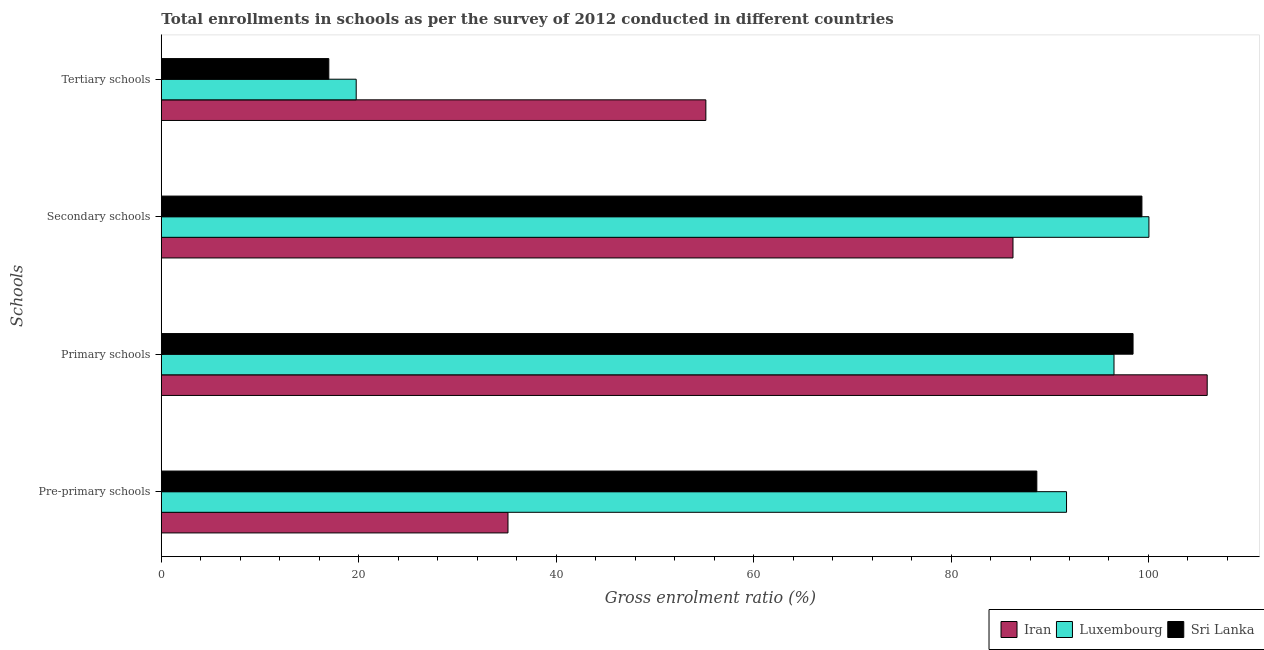How many different coloured bars are there?
Your answer should be compact. 3. How many groups of bars are there?
Your answer should be compact. 4. Are the number of bars on each tick of the Y-axis equal?
Ensure brevity in your answer.  Yes. How many bars are there on the 1st tick from the top?
Make the answer very short. 3. What is the label of the 3rd group of bars from the top?
Offer a very short reply. Primary schools. What is the gross enrolment ratio in tertiary schools in Sri Lanka?
Provide a succinct answer. 16.97. Across all countries, what is the maximum gross enrolment ratio in tertiary schools?
Offer a very short reply. 55.16. Across all countries, what is the minimum gross enrolment ratio in tertiary schools?
Keep it short and to the point. 16.97. In which country was the gross enrolment ratio in tertiary schools maximum?
Your response must be concise. Iran. In which country was the gross enrolment ratio in primary schools minimum?
Offer a very short reply. Luxembourg. What is the total gross enrolment ratio in tertiary schools in the graph?
Provide a short and direct response. 91.88. What is the difference between the gross enrolment ratio in pre-primary schools in Iran and that in Luxembourg?
Offer a very short reply. -56.58. What is the difference between the gross enrolment ratio in primary schools in Sri Lanka and the gross enrolment ratio in tertiary schools in Luxembourg?
Your response must be concise. 78.7. What is the average gross enrolment ratio in tertiary schools per country?
Make the answer very short. 30.63. What is the difference between the gross enrolment ratio in secondary schools and gross enrolment ratio in pre-primary schools in Iran?
Your response must be concise. 51.16. In how many countries, is the gross enrolment ratio in tertiary schools greater than 84 %?
Your answer should be very brief. 0. What is the ratio of the gross enrolment ratio in primary schools in Luxembourg to that in Sri Lanka?
Your answer should be very brief. 0.98. Is the gross enrolment ratio in tertiary schools in Iran less than that in Luxembourg?
Provide a succinct answer. No. What is the difference between the highest and the second highest gross enrolment ratio in primary schools?
Your answer should be very brief. 7.51. What is the difference between the highest and the lowest gross enrolment ratio in primary schools?
Your answer should be compact. 9.44. Is it the case that in every country, the sum of the gross enrolment ratio in secondary schools and gross enrolment ratio in primary schools is greater than the sum of gross enrolment ratio in pre-primary schools and gross enrolment ratio in tertiary schools?
Ensure brevity in your answer.  Yes. What does the 3rd bar from the top in Tertiary schools represents?
Your answer should be compact. Iran. What does the 3rd bar from the bottom in Primary schools represents?
Make the answer very short. Sri Lanka. Is it the case that in every country, the sum of the gross enrolment ratio in pre-primary schools and gross enrolment ratio in primary schools is greater than the gross enrolment ratio in secondary schools?
Your answer should be very brief. Yes. Are all the bars in the graph horizontal?
Provide a short and direct response. Yes. How many countries are there in the graph?
Keep it short and to the point. 3. Does the graph contain any zero values?
Keep it short and to the point. No. Does the graph contain grids?
Offer a very short reply. No. How are the legend labels stacked?
Keep it short and to the point. Horizontal. What is the title of the graph?
Provide a succinct answer. Total enrollments in schools as per the survey of 2012 conducted in different countries. What is the label or title of the X-axis?
Your answer should be very brief. Gross enrolment ratio (%). What is the label or title of the Y-axis?
Offer a terse response. Schools. What is the Gross enrolment ratio (%) in Iran in Pre-primary schools?
Your answer should be very brief. 35.12. What is the Gross enrolment ratio (%) of Luxembourg in Pre-primary schools?
Offer a terse response. 91.7. What is the Gross enrolment ratio (%) of Sri Lanka in Pre-primary schools?
Make the answer very short. 88.69. What is the Gross enrolment ratio (%) in Iran in Primary schools?
Your answer should be very brief. 105.95. What is the Gross enrolment ratio (%) of Luxembourg in Primary schools?
Make the answer very short. 96.51. What is the Gross enrolment ratio (%) of Sri Lanka in Primary schools?
Give a very brief answer. 98.44. What is the Gross enrolment ratio (%) of Iran in Secondary schools?
Offer a very short reply. 86.28. What is the Gross enrolment ratio (%) of Luxembourg in Secondary schools?
Provide a succinct answer. 100.05. What is the Gross enrolment ratio (%) of Sri Lanka in Secondary schools?
Your response must be concise. 99.34. What is the Gross enrolment ratio (%) of Iran in Tertiary schools?
Ensure brevity in your answer.  55.16. What is the Gross enrolment ratio (%) in Luxembourg in Tertiary schools?
Make the answer very short. 19.74. What is the Gross enrolment ratio (%) in Sri Lanka in Tertiary schools?
Your response must be concise. 16.97. Across all Schools, what is the maximum Gross enrolment ratio (%) of Iran?
Ensure brevity in your answer.  105.95. Across all Schools, what is the maximum Gross enrolment ratio (%) in Luxembourg?
Provide a short and direct response. 100.05. Across all Schools, what is the maximum Gross enrolment ratio (%) of Sri Lanka?
Give a very brief answer. 99.34. Across all Schools, what is the minimum Gross enrolment ratio (%) in Iran?
Offer a very short reply. 35.12. Across all Schools, what is the minimum Gross enrolment ratio (%) in Luxembourg?
Provide a succinct answer. 19.74. Across all Schools, what is the minimum Gross enrolment ratio (%) in Sri Lanka?
Your answer should be compact. 16.97. What is the total Gross enrolment ratio (%) in Iran in the graph?
Offer a terse response. 282.51. What is the total Gross enrolment ratio (%) of Luxembourg in the graph?
Keep it short and to the point. 308. What is the total Gross enrolment ratio (%) of Sri Lanka in the graph?
Provide a short and direct response. 303.44. What is the difference between the Gross enrolment ratio (%) of Iran in Pre-primary schools and that in Primary schools?
Provide a short and direct response. -70.83. What is the difference between the Gross enrolment ratio (%) of Luxembourg in Pre-primary schools and that in Primary schools?
Keep it short and to the point. -4.81. What is the difference between the Gross enrolment ratio (%) of Sri Lanka in Pre-primary schools and that in Primary schools?
Keep it short and to the point. -9.75. What is the difference between the Gross enrolment ratio (%) in Iran in Pre-primary schools and that in Secondary schools?
Your answer should be compact. -51.16. What is the difference between the Gross enrolment ratio (%) in Luxembourg in Pre-primary schools and that in Secondary schools?
Keep it short and to the point. -8.35. What is the difference between the Gross enrolment ratio (%) in Sri Lanka in Pre-primary schools and that in Secondary schools?
Provide a succinct answer. -10.65. What is the difference between the Gross enrolment ratio (%) of Iran in Pre-primary schools and that in Tertiary schools?
Offer a terse response. -20.05. What is the difference between the Gross enrolment ratio (%) of Luxembourg in Pre-primary schools and that in Tertiary schools?
Offer a terse response. 71.96. What is the difference between the Gross enrolment ratio (%) of Sri Lanka in Pre-primary schools and that in Tertiary schools?
Provide a succinct answer. 71.73. What is the difference between the Gross enrolment ratio (%) of Iran in Primary schools and that in Secondary schools?
Give a very brief answer. 19.67. What is the difference between the Gross enrolment ratio (%) in Luxembourg in Primary schools and that in Secondary schools?
Ensure brevity in your answer.  -3.54. What is the difference between the Gross enrolment ratio (%) in Sri Lanka in Primary schools and that in Secondary schools?
Make the answer very short. -0.9. What is the difference between the Gross enrolment ratio (%) of Iran in Primary schools and that in Tertiary schools?
Your answer should be very brief. 50.79. What is the difference between the Gross enrolment ratio (%) in Luxembourg in Primary schools and that in Tertiary schools?
Offer a terse response. 76.77. What is the difference between the Gross enrolment ratio (%) of Sri Lanka in Primary schools and that in Tertiary schools?
Offer a terse response. 81.47. What is the difference between the Gross enrolment ratio (%) in Iran in Secondary schools and that in Tertiary schools?
Your answer should be compact. 31.11. What is the difference between the Gross enrolment ratio (%) in Luxembourg in Secondary schools and that in Tertiary schools?
Offer a terse response. 80.3. What is the difference between the Gross enrolment ratio (%) in Sri Lanka in Secondary schools and that in Tertiary schools?
Your response must be concise. 82.37. What is the difference between the Gross enrolment ratio (%) in Iran in Pre-primary schools and the Gross enrolment ratio (%) in Luxembourg in Primary schools?
Provide a succinct answer. -61.39. What is the difference between the Gross enrolment ratio (%) in Iran in Pre-primary schools and the Gross enrolment ratio (%) in Sri Lanka in Primary schools?
Provide a short and direct response. -63.32. What is the difference between the Gross enrolment ratio (%) of Luxembourg in Pre-primary schools and the Gross enrolment ratio (%) of Sri Lanka in Primary schools?
Provide a short and direct response. -6.74. What is the difference between the Gross enrolment ratio (%) in Iran in Pre-primary schools and the Gross enrolment ratio (%) in Luxembourg in Secondary schools?
Make the answer very short. -64.93. What is the difference between the Gross enrolment ratio (%) of Iran in Pre-primary schools and the Gross enrolment ratio (%) of Sri Lanka in Secondary schools?
Ensure brevity in your answer.  -64.22. What is the difference between the Gross enrolment ratio (%) in Luxembourg in Pre-primary schools and the Gross enrolment ratio (%) in Sri Lanka in Secondary schools?
Make the answer very short. -7.64. What is the difference between the Gross enrolment ratio (%) in Iran in Pre-primary schools and the Gross enrolment ratio (%) in Luxembourg in Tertiary schools?
Give a very brief answer. 15.38. What is the difference between the Gross enrolment ratio (%) of Iran in Pre-primary schools and the Gross enrolment ratio (%) of Sri Lanka in Tertiary schools?
Provide a short and direct response. 18.15. What is the difference between the Gross enrolment ratio (%) in Luxembourg in Pre-primary schools and the Gross enrolment ratio (%) in Sri Lanka in Tertiary schools?
Give a very brief answer. 74.73. What is the difference between the Gross enrolment ratio (%) in Iran in Primary schools and the Gross enrolment ratio (%) in Luxembourg in Secondary schools?
Your answer should be very brief. 5.9. What is the difference between the Gross enrolment ratio (%) in Iran in Primary schools and the Gross enrolment ratio (%) in Sri Lanka in Secondary schools?
Ensure brevity in your answer.  6.61. What is the difference between the Gross enrolment ratio (%) in Luxembourg in Primary schools and the Gross enrolment ratio (%) in Sri Lanka in Secondary schools?
Provide a short and direct response. -2.83. What is the difference between the Gross enrolment ratio (%) in Iran in Primary schools and the Gross enrolment ratio (%) in Luxembourg in Tertiary schools?
Make the answer very short. 86.21. What is the difference between the Gross enrolment ratio (%) in Iran in Primary schools and the Gross enrolment ratio (%) in Sri Lanka in Tertiary schools?
Provide a short and direct response. 88.98. What is the difference between the Gross enrolment ratio (%) in Luxembourg in Primary schools and the Gross enrolment ratio (%) in Sri Lanka in Tertiary schools?
Provide a short and direct response. 79.54. What is the difference between the Gross enrolment ratio (%) of Iran in Secondary schools and the Gross enrolment ratio (%) of Luxembourg in Tertiary schools?
Offer a terse response. 66.53. What is the difference between the Gross enrolment ratio (%) of Iran in Secondary schools and the Gross enrolment ratio (%) of Sri Lanka in Tertiary schools?
Provide a succinct answer. 69.31. What is the difference between the Gross enrolment ratio (%) in Luxembourg in Secondary schools and the Gross enrolment ratio (%) in Sri Lanka in Tertiary schools?
Make the answer very short. 83.08. What is the average Gross enrolment ratio (%) in Iran per Schools?
Offer a terse response. 70.63. What is the average Gross enrolment ratio (%) of Luxembourg per Schools?
Your answer should be very brief. 77. What is the average Gross enrolment ratio (%) in Sri Lanka per Schools?
Your answer should be very brief. 75.86. What is the difference between the Gross enrolment ratio (%) in Iran and Gross enrolment ratio (%) in Luxembourg in Pre-primary schools?
Ensure brevity in your answer.  -56.58. What is the difference between the Gross enrolment ratio (%) in Iran and Gross enrolment ratio (%) in Sri Lanka in Pre-primary schools?
Offer a terse response. -53.57. What is the difference between the Gross enrolment ratio (%) in Luxembourg and Gross enrolment ratio (%) in Sri Lanka in Pre-primary schools?
Keep it short and to the point. 3.01. What is the difference between the Gross enrolment ratio (%) of Iran and Gross enrolment ratio (%) of Luxembourg in Primary schools?
Provide a succinct answer. 9.44. What is the difference between the Gross enrolment ratio (%) of Iran and Gross enrolment ratio (%) of Sri Lanka in Primary schools?
Make the answer very short. 7.51. What is the difference between the Gross enrolment ratio (%) in Luxembourg and Gross enrolment ratio (%) in Sri Lanka in Primary schools?
Offer a terse response. -1.93. What is the difference between the Gross enrolment ratio (%) of Iran and Gross enrolment ratio (%) of Luxembourg in Secondary schools?
Your response must be concise. -13.77. What is the difference between the Gross enrolment ratio (%) in Iran and Gross enrolment ratio (%) in Sri Lanka in Secondary schools?
Keep it short and to the point. -13.06. What is the difference between the Gross enrolment ratio (%) in Luxembourg and Gross enrolment ratio (%) in Sri Lanka in Secondary schools?
Ensure brevity in your answer.  0.71. What is the difference between the Gross enrolment ratio (%) in Iran and Gross enrolment ratio (%) in Luxembourg in Tertiary schools?
Your answer should be compact. 35.42. What is the difference between the Gross enrolment ratio (%) of Iran and Gross enrolment ratio (%) of Sri Lanka in Tertiary schools?
Offer a terse response. 38.2. What is the difference between the Gross enrolment ratio (%) in Luxembourg and Gross enrolment ratio (%) in Sri Lanka in Tertiary schools?
Keep it short and to the point. 2.78. What is the ratio of the Gross enrolment ratio (%) in Iran in Pre-primary schools to that in Primary schools?
Your answer should be very brief. 0.33. What is the ratio of the Gross enrolment ratio (%) of Luxembourg in Pre-primary schools to that in Primary schools?
Your answer should be compact. 0.95. What is the ratio of the Gross enrolment ratio (%) in Sri Lanka in Pre-primary schools to that in Primary schools?
Offer a terse response. 0.9. What is the ratio of the Gross enrolment ratio (%) in Iran in Pre-primary schools to that in Secondary schools?
Provide a succinct answer. 0.41. What is the ratio of the Gross enrolment ratio (%) of Luxembourg in Pre-primary schools to that in Secondary schools?
Keep it short and to the point. 0.92. What is the ratio of the Gross enrolment ratio (%) in Sri Lanka in Pre-primary schools to that in Secondary schools?
Your answer should be very brief. 0.89. What is the ratio of the Gross enrolment ratio (%) of Iran in Pre-primary schools to that in Tertiary schools?
Give a very brief answer. 0.64. What is the ratio of the Gross enrolment ratio (%) of Luxembourg in Pre-primary schools to that in Tertiary schools?
Offer a terse response. 4.64. What is the ratio of the Gross enrolment ratio (%) in Sri Lanka in Pre-primary schools to that in Tertiary schools?
Offer a very short reply. 5.23. What is the ratio of the Gross enrolment ratio (%) in Iran in Primary schools to that in Secondary schools?
Provide a short and direct response. 1.23. What is the ratio of the Gross enrolment ratio (%) of Luxembourg in Primary schools to that in Secondary schools?
Provide a short and direct response. 0.96. What is the ratio of the Gross enrolment ratio (%) in Iran in Primary schools to that in Tertiary schools?
Your answer should be very brief. 1.92. What is the ratio of the Gross enrolment ratio (%) of Luxembourg in Primary schools to that in Tertiary schools?
Ensure brevity in your answer.  4.89. What is the ratio of the Gross enrolment ratio (%) in Sri Lanka in Primary schools to that in Tertiary schools?
Provide a succinct answer. 5.8. What is the ratio of the Gross enrolment ratio (%) of Iran in Secondary schools to that in Tertiary schools?
Your response must be concise. 1.56. What is the ratio of the Gross enrolment ratio (%) of Luxembourg in Secondary schools to that in Tertiary schools?
Provide a succinct answer. 5.07. What is the ratio of the Gross enrolment ratio (%) of Sri Lanka in Secondary schools to that in Tertiary schools?
Make the answer very short. 5.85. What is the difference between the highest and the second highest Gross enrolment ratio (%) of Iran?
Keep it short and to the point. 19.67. What is the difference between the highest and the second highest Gross enrolment ratio (%) in Luxembourg?
Your answer should be compact. 3.54. What is the difference between the highest and the second highest Gross enrolment ratio (%) in Sri Lanka?
Keep it short and to the point. 0.9. What is the difference between the highest and the lowest Gross enrolment ratio (%) of Iran?
Your answer should be compact. 70.83. What is the difference between the highest and the lowest Gross enrolment ratio (%) in Luxembourg?
Your response must be concise. 80.3. What is the difference between the highest and the lowest Gross enrolment ratio (%) of Sri Lanka?
Provide a succinct answer. 82.37. 